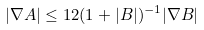Convert formula to latex. <formula><loc_0><loc_0><loc_500><loc_500>| \nabla A | \leq 1 2 ( 1 + | B | ) ^ { - 1 } | \nabla B |</formula> 